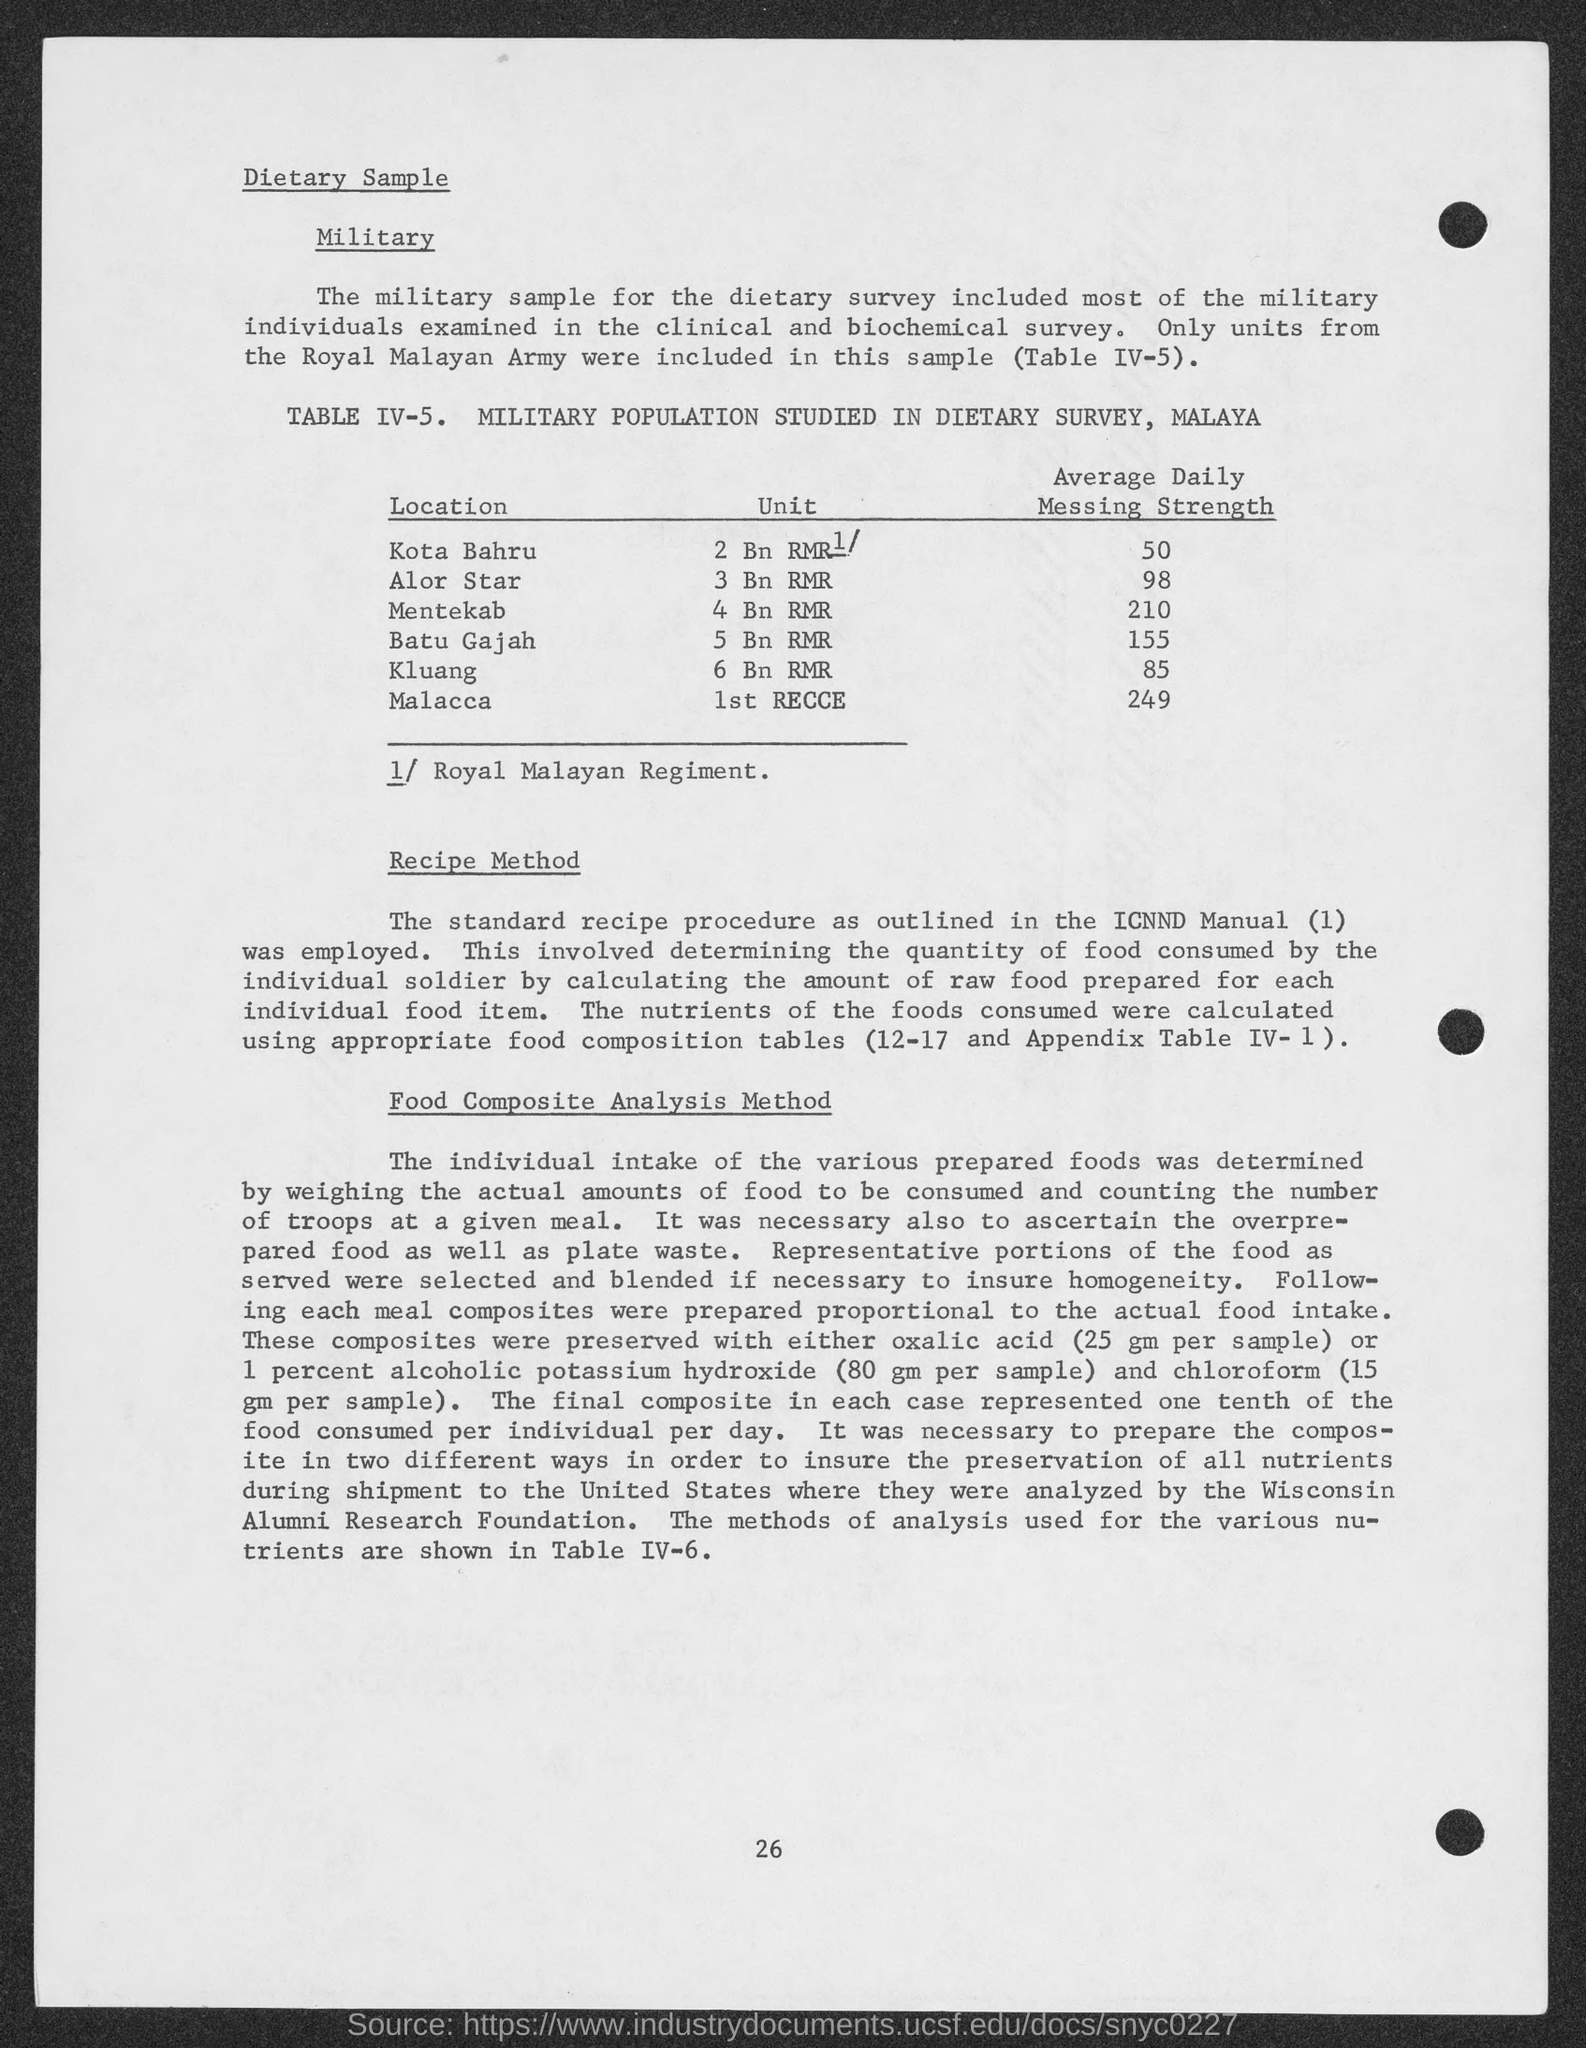What is the Average Daily Messing Strength for Mentekab?
 210 